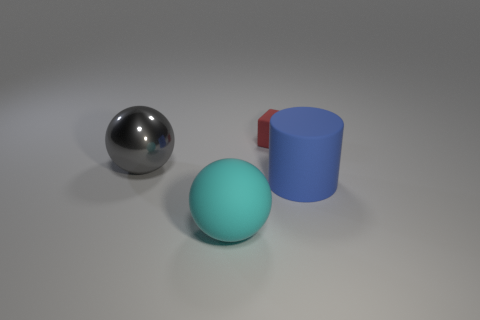Add 3 balls. How many objects exist? 7 Subtract all cylinders. How many objects are left? 3 Subtract 0 cyan cylinders. How many objects are left? 4 Subtract all large gray metal things. Subtract all big cyan rubber balls. How many objects are left? 2 Add 1 big gray metallic things. How many big gray metallic things are left? 2 Add 3 large brown rubber cylinders. How many large brown rubber cylinders exist? 3 